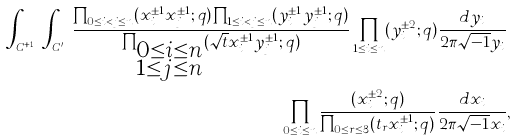Convert formula to latex. <formula><loc_0><loc_0><loc_500><loc_500>\int _ { C ^ { n + 1 } } \int _ { C ^ { \prime n } } \frac { \prod _ { 0 \leq i < j \leq n } ( x _ { i } ^ { \pm 1 } x _ { j } ^ { \pm 1 } ; q ) \prod _ { 1 \leq i < j \leq n } ( y _ { i } ^ { \pm 1 } y _ { j } ^ { \pm 1 } ; q ) } { \prod _ { \substack { 0 \leq i \leq n \\ 1 \leq j \leq n } } ( \sqrt { t } x _ { i } ^ { \pm 1 } y _ { j } ^ { \pm 1 } ; q ) } \prod _ { 1 \leq i \leq n } ( y _ { i } ^ { \pm 2 } ; q ) \frac { d y _ { i } } { 2 \pi \sqrt { - 1 } y _ { i } } & \\ \prod _ { 0 \leq i \leq n } \frac { ( x _ { i } ^ { \pm 2 } ; q ) } { \prod _ { 0 \leq r \leq 3 } ( t _ { r } x _ { i } ^ { \pm 1 } ; q ) } \frac { d x _ { i } } { 2 \pi \sqrt { - 1 } x _ { i } } & ,</formula> 